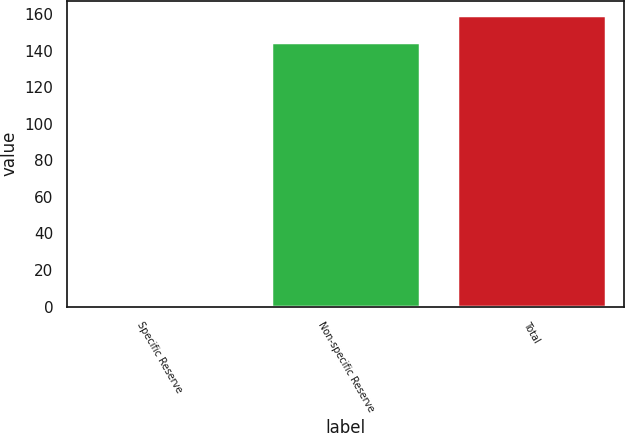<chart> <loc_0><loc_0><loc_500><loc_500><bar_chart><fcel>Specific Reserve<fcel>Non-specific Reserve<fcel>Total<nl><fcel>0.6<fcel>144.9<fcel>159.39<nl></chart> 